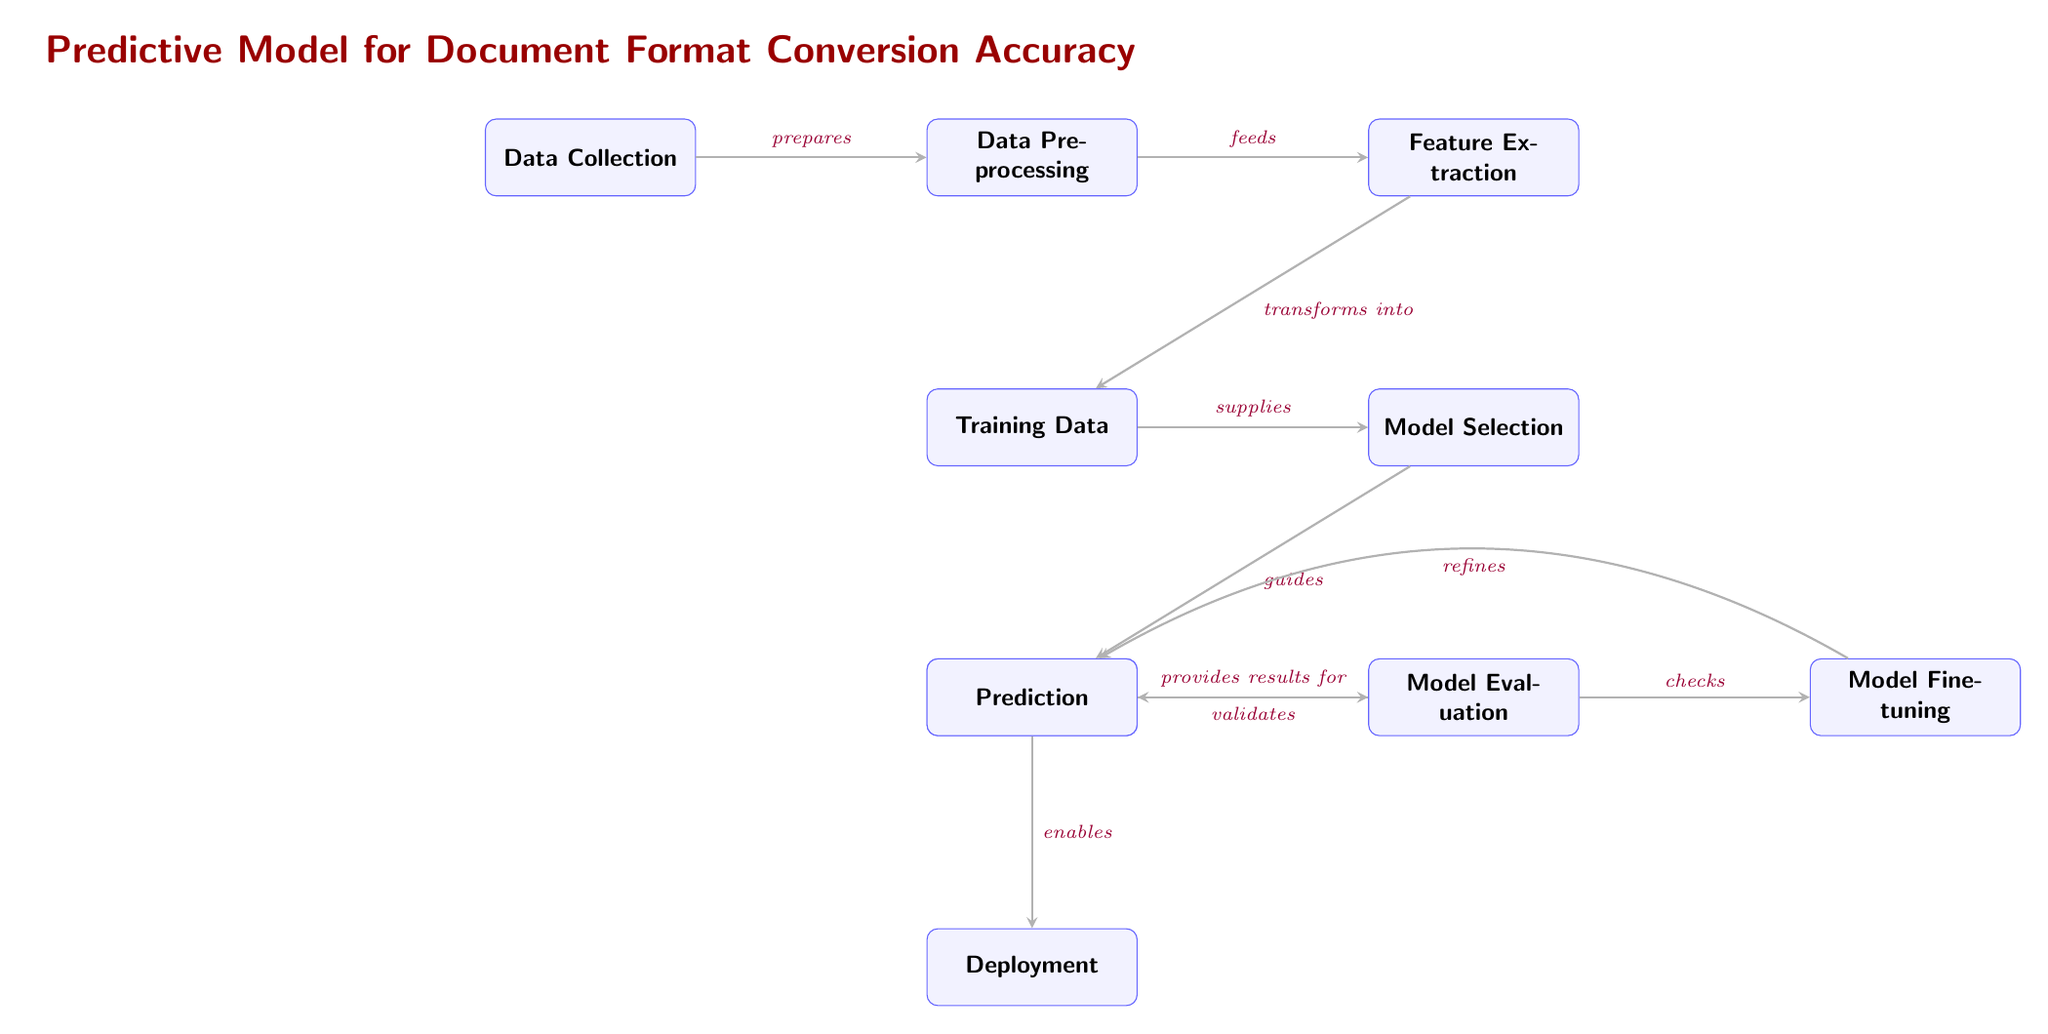What is the first step in the predictive model process? The first step is labeled as "Data Collection," which is the starting point of the process depicted in the diagram.
Answer: Data Collection How many main nodes are present in the diagram? By counting each distinct labeled node in the diagram, we identify a total of 10 nodes that represent different stages in the predictive model process.
Answer: 10 What is the relationship between "Data Preprocessing" and "Feature Extraction"? The relationship is established by the edge that shows "Data Preprocessing" feeds into "Feature Extraction," indicating that the output of the former serves as input for the latter.
Answer: feeds Which node follows "Model Selection"? "Model Training" directly follows "Model Selection" based on the downward connection depicted in the diagram.
Answer: Model Training What action is associated with "Prediction"? The action associated with "Prediction" is labeled as "validates," indicating that the prediction stage provides validation for the preceding model evaluation stage.
Answer: validates What is the last step in the predictive model process? The final step in the process as per the diagram is labeled "Deployment," marking the conclusion of the workflow for document format conversion accuracy prediction.
Answer: Deployment Which node is responsible for "refines"? The node that is responsible for the action "refines" is "Model Fine-tuning," as indicated in the diagram where it loops back to "Model Training."
Answer: Model Fine-tuning How does "Training Data" connect to other nodes? "Training Data" connects to "Model Selection," as it supplies the necessary input for selecting the appropriate model based on the training dataset.
Answer: supplies What process follows after "Model Evaluation"? The process that follows "Model Evaluation" is "Prediction," as shown in the diagram through an arrow indicating a sequential flow from evaluation to prediction.
Answer: Prediction 